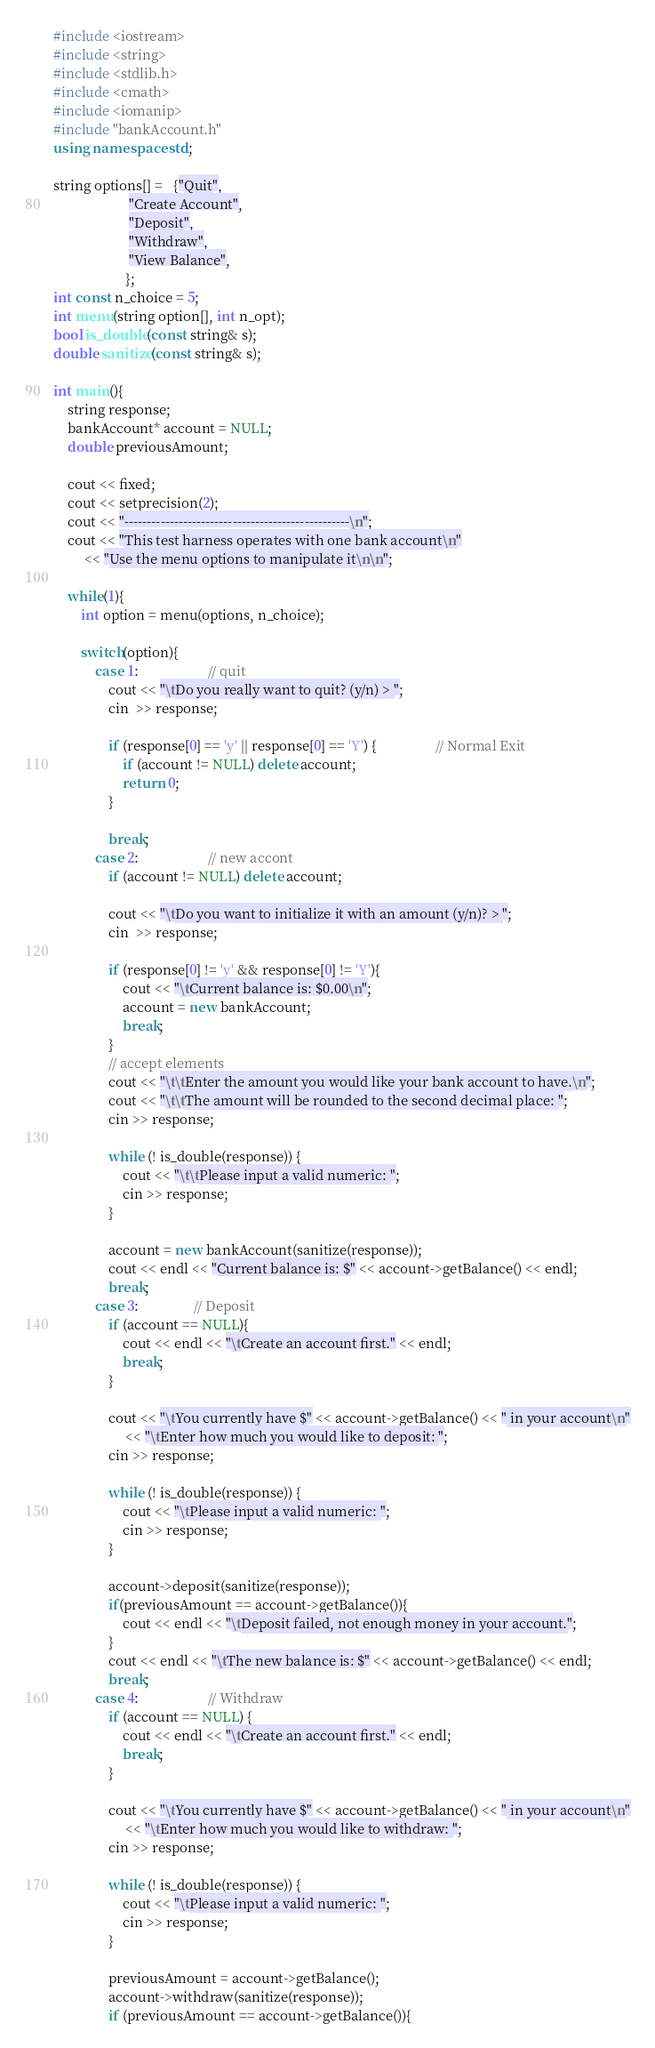Convert code to text. <code><loc_0><loc_0><loc_500><loc_500><_C++_>#include <iostream>
#include <string>
#include <stdlib.h>
#include <cmath>
#include <iomanip>
#include "bankAccount.h"
using namespace std;

string options[] =   {"Quit",
					  "Create Account",
                      "Deposit",
                      "Withdraw",
                      "View Balance",
                     };
int const n_choice = 5;
int menu(string option[], int n_opt);
bool is_double(const string& s);
double sanitize(const string& s);

int main(){
	string response;
	bankAccount* account = NULL;
	double previousAmount;

	cout << fixed;
	cout << setprecision(2);
	cout << "--------------------------------------------------\n";
    cout << "This test harness operates with one bank account\n"
         << "Use the menu options to manipulate it\n\n";

	while(1){
		int option = menu(options, n_choice);

		switch(option){
			case 1:					// quit
				cout << "\tDo you really want to quit? (y/n) > ";
                cin  >> response;

                if (response[0] == 'y' || response[0] == 'Y') {                 // Normal Exit
                    if (account != NULL) delete account;
                    return 0;
                }

	            break;
	        case 2:					// new accont
	        	if (account != NULL) delete account;

                cout << "\tDo you want to initialize it with an amount (y/n)? > ";
                cin  >> response;

                if (response[0] != 'y' && response[0] != 'Y'){
                	cout << "\tCurrent balance is: $0.00\n";
                	account = new bankAccount;
                    break;
                } 
                // accept elements
                cout << "\t\tEnter the amount you would like your bank account to have.\n";
                cout << "\t\tThe amount will be rounded to the second decimal place: ";
                cin >> response;

                while (! is_double(response)) {
                    cout << "\t\tPlease input a valid numeric: ";
                    cin >> response;
                }

                account = new bankAccount(sanitize(response));
                cout << endl << "Current balance is: $" << account->getBalance() << endl;
                break;
            case 3: 				// Deposit
            	if (account == NULL){
            		cout << endl << "\tCreate an account first." << endl;
            		break;
            	}

            	cout << "\tYou currently have $" << account->getBalance() << " in your account\n"
            		 << "\tEnter how much you would like to deposit: ";
            	cin >> response;

            	while (! is_double(response)) {
                    cout << "\tPlease input a valid numeric: ";
                    cin >> response;
                }

                account->deposit(sanitize(response));
                if(previousAmount == account->getBalance()){
                	cout << endl << "\tDeposit failed, not enough money in your account.";
                }
                cout << endl << "\tThe new balance is: $" << account->getBalance() << endl;
                break;
            case 4:					// Withdraw
            	if (account == NULL) {
            		cout << endl << "\tCreate an account first." << endl;
            		break;
            	}

            	cout << "\tYou currently have $" << account->getBalance() << " in your account\n"
            		 << "\tEnter how much you would like to withdraw: ";
            	cin >> response;

            	while (! is_double(response)) {
                    cout << "\tPlease input a valid numeric: ";
                    cin >> response;
                }

                previousAmount = account->getBalance();
                account->withdraw(sanitize(response));
                if (previousAmount == account->getBalance()){</code> 